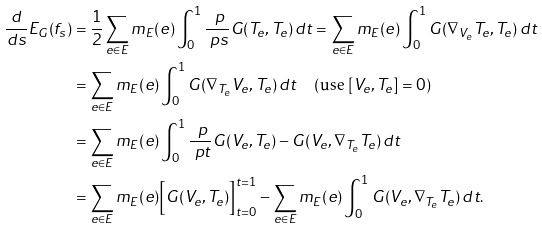<formula> <loc_0><loc_0><loc_500><loc_500>\frac { d } { d s } E _ { G } ( f _ { s } ) & = \frac { 1 } { 2 } \sum _ { e \in E } m _ { E } ( e ) \int _ { 0 } ^ { 1 } \frac { \ p } { \ p s } G ( T _ { e } , T _ { e } ) \, d t = \sum _ { e \in E } m _ { E } ( e ) \int _ { 0 } ^ { 1 } G ( \nabla _ { V _ { e } } T _ { e } , T _ { e } ) \, d t \\ & = \sum _ { e \in E } m _ { E } ( e ) \int _ { 0 } ^ { 1 } G ( \nabla _ { T _ { e } } V _ { e } , T _ { e } ) \, d t \quad \text {(use $[V_{e}, T_{e}]=0$)} \\ & = \sum _ { e \in E } m _ { E } ( e ) \int _ { 0 } ^ { 1 } \frac { \ p } { \ p t } G ( V _ { e } , T _ { e } ) - G ( V _ { e } , \nabla _ { T _ { e } } T _ { e } ) \, d t \\ & = \sum _ { e \in E } m _ { E } ( e ) \Big { [ } G ( V _ { e } , T _ { e } ) \Big { ] } _ { t = 0 } ^ { t = 1 } - \sum _ { e \in E } m _ { E } ( e ) \int _ { 0 } ^ { 1 } G ( V _ { e } , \nabla _ { T _ { e } } T _ { e } ) \, d t .</formula> 